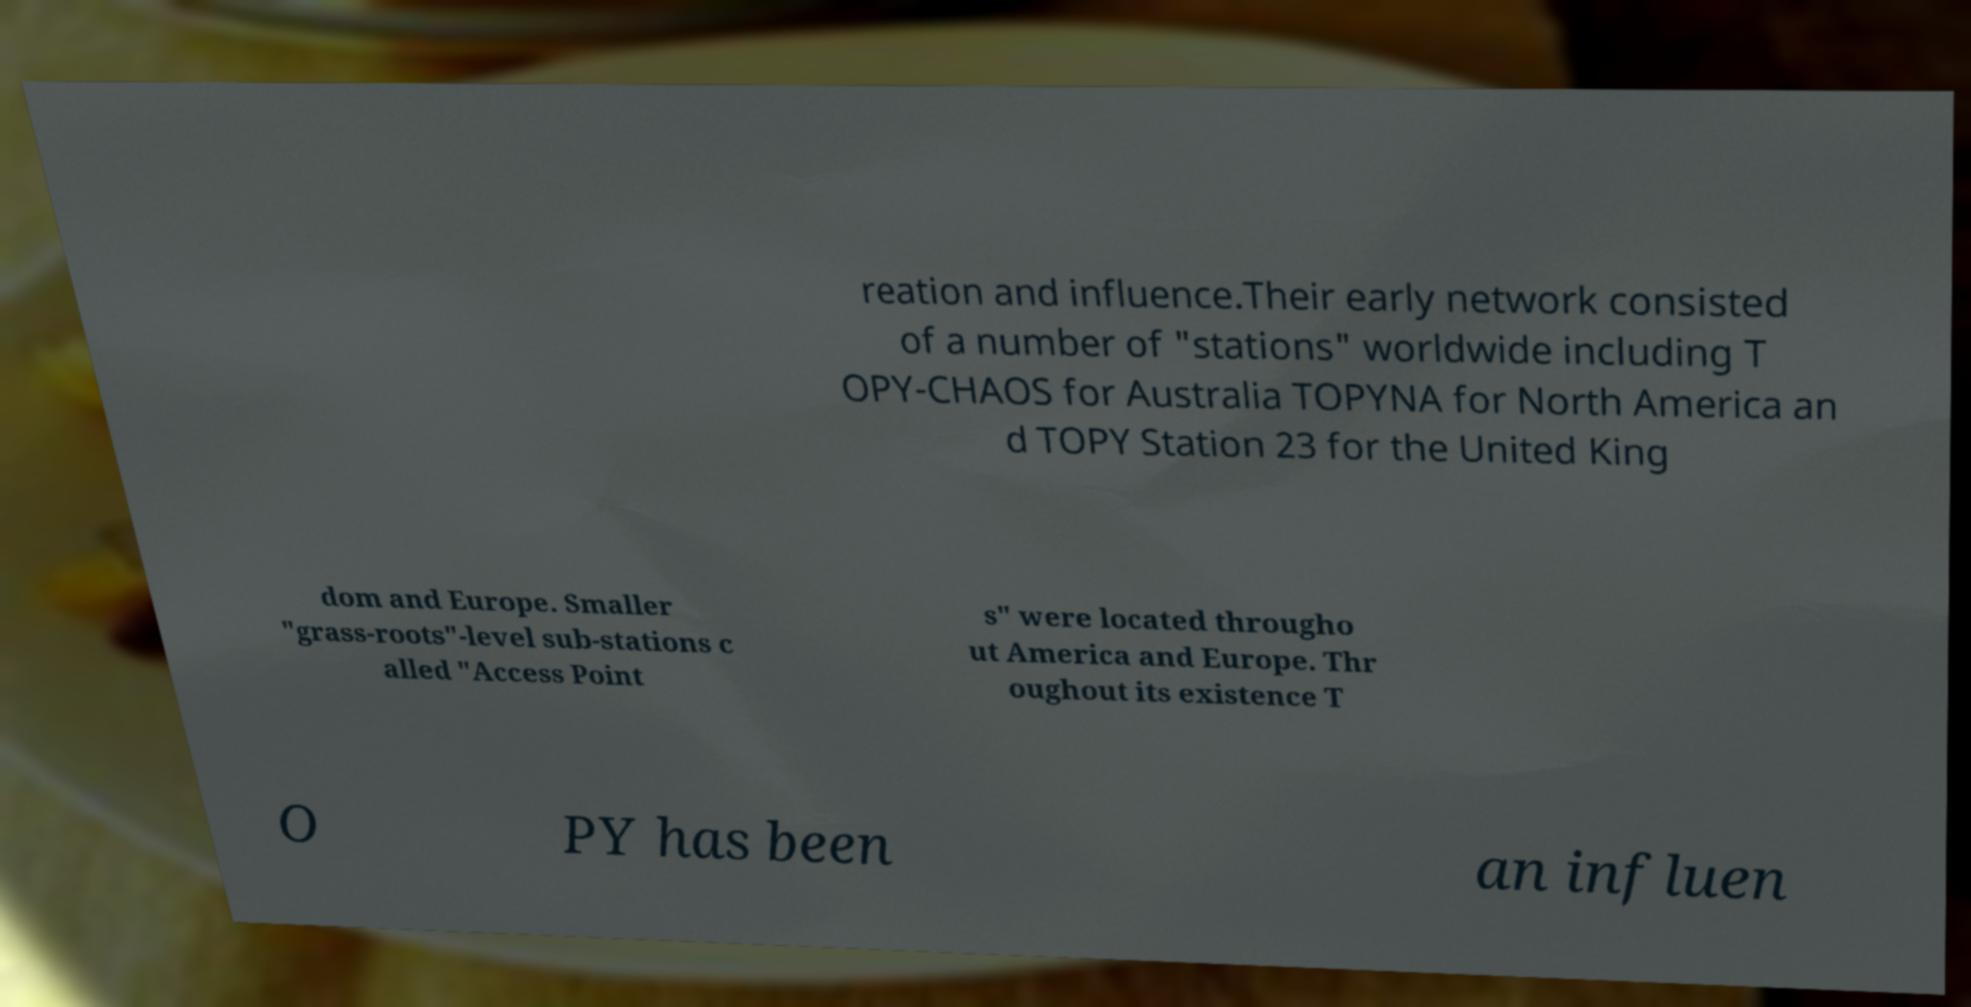Can you read and provide the text displayed in the image?This photo seems to have some interesting text. Can you extract and type it out for me? reation and influence.Their early network consisted of a number of "stations" worldwide including T OPY-CHAOS for Australia TOPYNA for North America an d TOPY Station 23 for the United King dom and Europe. Smaller "grass-roots"-level sub-stations c alled "Access Point s" were located througho ut America and Europe. Thr oughout its existence T O PY has been an influen 